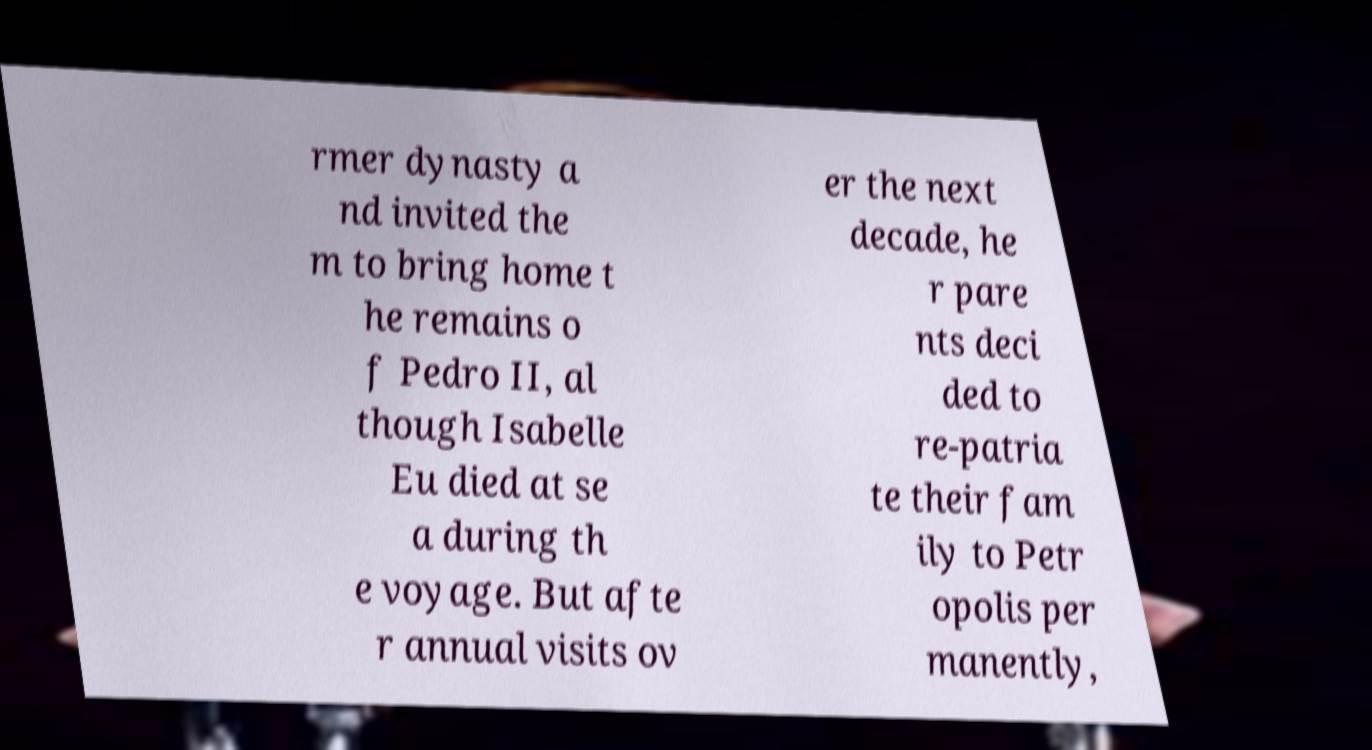I need the written content from this picture converted into text. Can you do that? rmer dynasty a nd invited the m to bring home t he remains o f Pedro II, al though Isabelle Eu died at se a during th e voyage. But afte r annual visits ov er the next decade, he r pare nts deci ded to re-patria te their fam ily to Petr opolis per manently, 